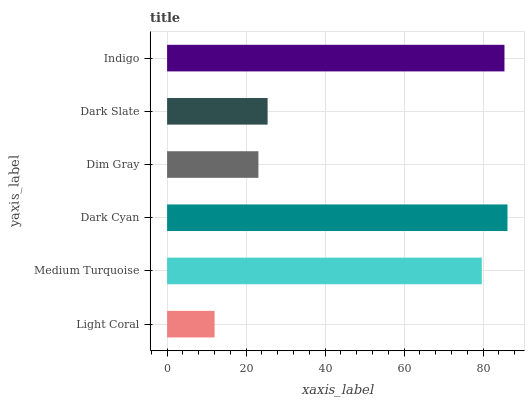Is Light Coral the minimum?
Answer yes or no. Yes. Is Dark Cyan the maximum?
Answer yes or no. Yes. Is Medium Turquoise the minimum?
Answer yes or no. No. Is Medium Turquoise the maximum?
Answer yes or no. No. Is Medium Turquoise greater than Light Coral?
Answer yes or no. Yes. Is Light Coral less than Medium Turquoise?
Answer yes or no. Yes. Is Light Coral greater than Medium Turquoise?
Answer yes or no. No. Is Medium Turquoise less than Light Coral?
Answer yes or no. No. Is Medium Turquoise the high median?
Answer yes or no. Yes. Is Dark Slate the low median?
Answer yes or no. Yes. Is Light Coral the high median?
Answer yes or no. No. Is Light Coral the low median?
Answer yes or no. No. 